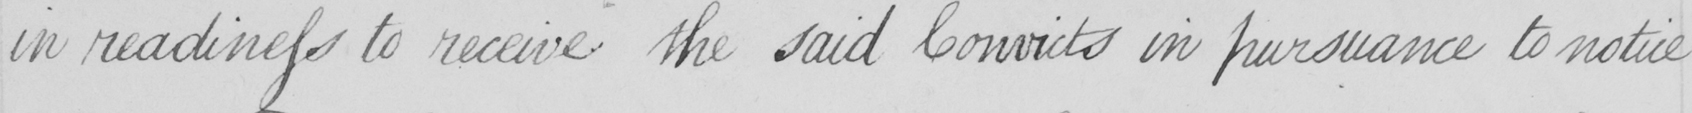Can you read and transcribe this handwriting? in readiness to receive the said Convicts in pursuance to notice 